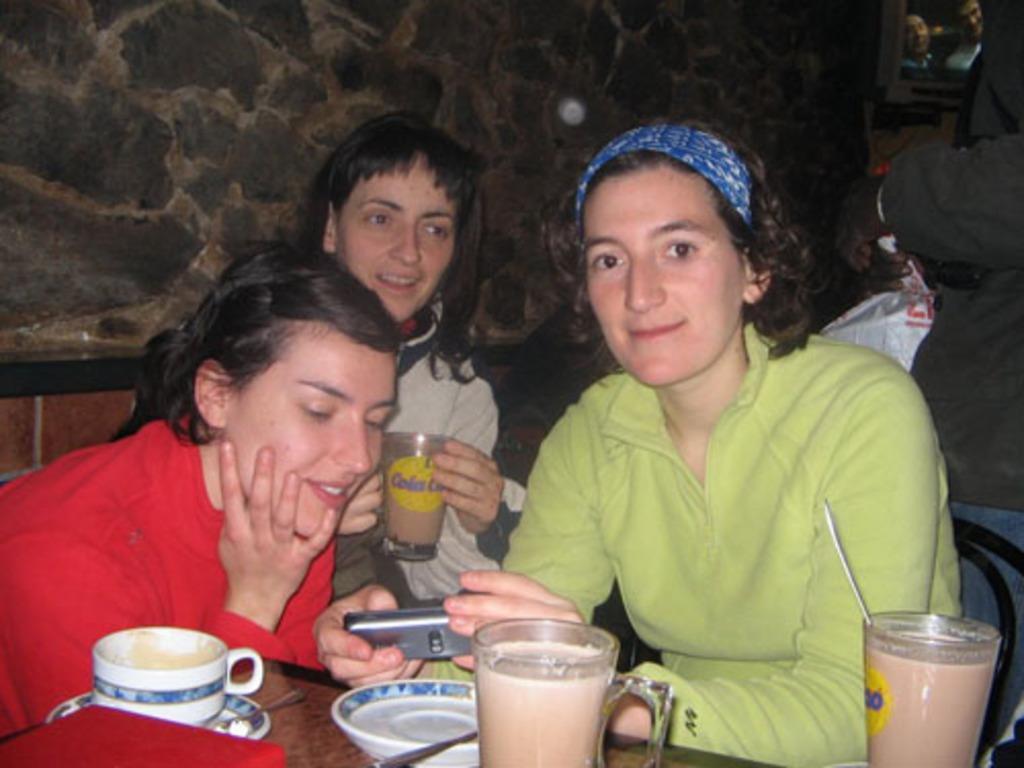Could you give a brief overview of what you see in this image? There is a group of people. They are sitting on a chairs. There is a table. There is a cup,saucer,glass and spoon on a table. On the right side we have a woman. She is holding a mobile. 